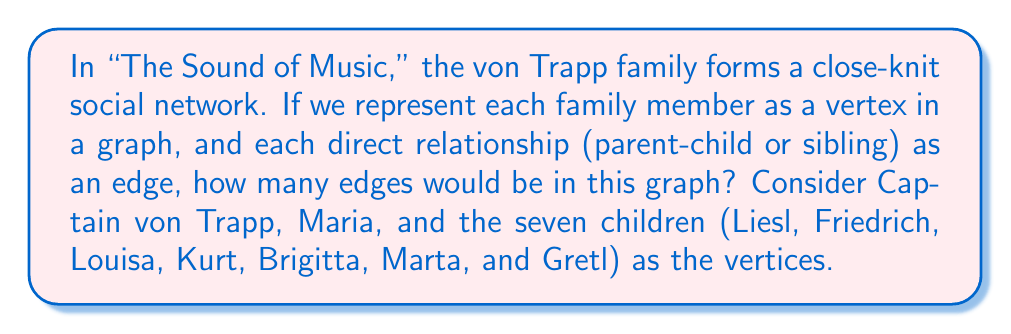Provide a solution to this math problem. Let's approach this step-by-step:

1) First, we need to count the number of vertices:
   - Captain von Trapp
   - Maria
   - 7 children
   Total vertices: $9$

2) Now, let's count the edges:
   a) Parent-child relationships:
      - Captain von Trapp to each child: $7$ edges
      - Maria to each child (after marriage): $7$ edges

   b) Sibling relationships:
      The number of edges between siblings can be calculated using the combination formula:
      $$\binom{7}{2} = \frac{7!}{2!(7-2)!} = \frac{7 \cdot 6}{2} = 21$$

   c) The edge between Captain von Trapp and Maria: $1$ edge

3) Total number of edges:
   $$7 + 7 + 21 + 1 = 36$$

This graph would be a complete graph $K_9$ if everyone were directly connected to everyone else. In a $K_9$, the number of edges would be:
$$\binom{9}{2} = \frac{9 \cdot 8}{2} = 36$$

Interestingly, our result matches this number, showing that in this representation, the von Trapp family forms a complete graph.
Answer: The graph representing the von Trapp family's social network in "The Sound of Music" would have $36$ edges. 